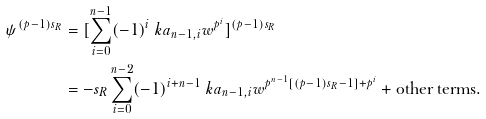Convert formula to latex. <formula><loc_0><loc_0><loc_500><loc_500>\psi ^ { ( p - 1 ) s _ { R } } & = [ \sum _ { i = 0 } ^ { n - 1 } ( - 1 ) ^ { i } \ k a _ { n - 1 , i } w ^ { p ^ { i } } ] ^ { ( p - 1 ) s _ { R } } \\ & = - s _ { R } \sum _ { i = 0 } ^ { n - 2 } ( - 1 ) ^ { i + n - 1 } \ k a _ { n - 1 , i } w ^ { p ^ { n - 1 } [ ( p - 1 ) s _ { R } - 1 ] + p ^ { i } } + \text {other terms.}</formula> 